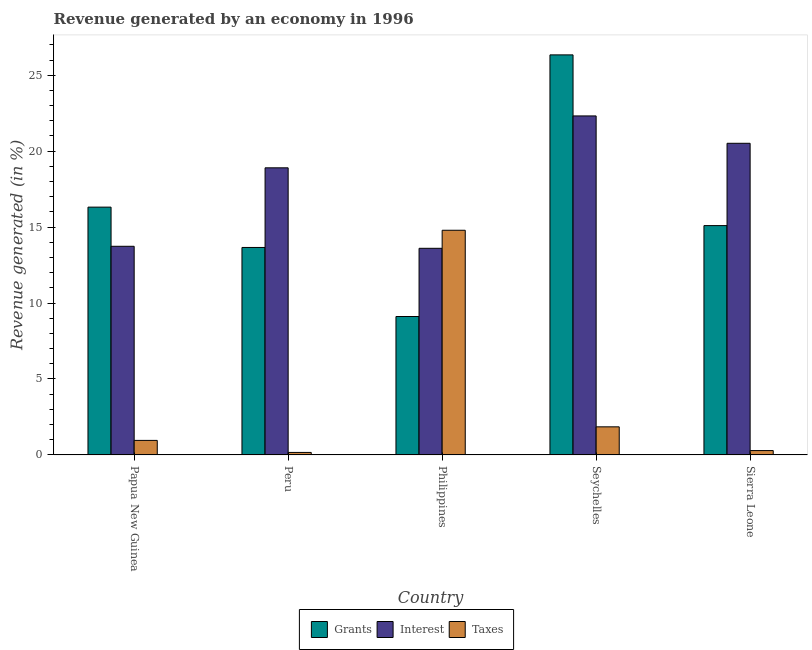How many different coloured bars are there?
Provide a short and direct response. 3. How many groups of bars are there?
Your answer should be very brief. 5. Are the number of bars per tick equal to the number of legend labels?
Your answer should be compact. Yes. How many bars are there on the 5th tick from the left?
Provide a succinct answer. 3. How many bars are there on the 2nd tick from the right?
Make the answer very short. 3. What is the label of the 1st group of bars from the left?
Keep it short and to the point. Papua New Guinea. In how many cases, is the number of bars for a given country not equal to the number of legend labels?
Give a very brief answer. 0. What is the percentage of revenue generated by interest in Philippines?
Your answer should be compact. 13.6. Across all countries, what is the maximum percentage of revenue generated by grants?
Provide a short and direct response. 26.34. Across all countries, what is the minimum percentage of revenue generated by taxes?
Keep it short and to the point. 0.16. In which country was the percentage of revenue generated by grants maximum?
Your response must be concise. Seychelles. In which country was the percentage of revenue generated by taxes minimum?
Your response must be concise. Peru. What is the total percentage of revenue generated by taxes in the graph?
Keep it short and to the point. 18.05. What is the difference between the percentage of revenue generated by taxes in Seychelles and that in Sierra Leone?
Make the answer very short. 1.56. What is the difference between the percentage of revenue generated by interest in Seychelles and the percentage of revenue generated by taxes in Peru?
Offer a very short reply. 22.16. What is the average percentage of revenue generated by interest per country?
Your answer should be compact. 17.82. What is the difference between the percentage of revenue generated by interest and percentage of revenue generated by grants in Philippines?
Give a very brief answer. 4.49. What is the ratio of the percentage of revenue generated by taxes in Peru to that in Sierra Leone?
Make the answer very short. 0.57. Is the difference between the percentage of revenue generated by taxes in Papua New Guinea and Peru greater than the difference between the percentage of revenue generated by interest in Papua New Guinea and Peru?
Your response must be concise. Yes. What is the difference between the highest and the second highest percentage of revenue generated by grants?
Offer a terse response. 10.03. What is the difference between the highest and the lowest percentage of revenue generated by interest?
Offer a terse response. 8.72. In how many countries, is the percentage of revenue generated by interest greater than the average percentage of revenue generated by interest taken over all countries?
Ensure brevity in your answer.  3. What does the 3rd bar from the left in Peru represents?
Ensure brevity in your answer.  Taxes. What does the 1st bar from the right in Papua New Guinea represents?
Your answer should be compact. Taxes. Are all the bars in the graph horizontal?
Keep it short and to the point. No. Does the graph contain any zero values?
Your answer should be compact. No. How are the legend labels stacked?
Make the answer very short. Horizontal. What is the title of the graph?
Offer a terse response. Revenue generated by an economy in 1996. Does "Spain" appear as one of the legend labels in the graph?
Keep it short and to the point. No. What is the label or title of the Y-axis?
Ensure brevity in your answer.  Revenue generated (in %). What is the Revenue generated (in %) in Grants in Papua New Guinea?
Provide a succinct answer. 16.32. What is the Revenue generated (in %) in Interest in Papua New Guinea?
Make the answer very short. 13.74. What is the Revenue generated (in %) of Taxes in Papua New Guinea?
Your answer should be compact. 0.96. What is the Revenue generated (in %) in Grants in Peru?
Keep it short and to the point. 13.66. What is the Revenue generated (in %) in Interest in Peru?
Make the answer very short. 18.9. What is the Revenue generated (in %) in Taxes in Peru?
Offer a very short reply. 0.16. What is the Revenue generated (in %) in Grants in Philippines?
Your answer should be very brief. 9.11. What is the Revenue generated (in %) in Interest in Philippines?
Provide a short and direct response. 13.6. What is the Revenue generated (in %) in Taxes in Philippines?
Make the answer very short. 14.79. What is the Revenue generated (in %) in Grants in Seychelles?
Make the answer very short. 26.34. What is the Revenue generated (in %) in Interest in Seychelles?
Your answer should be compact. 22.32. What is the Revenue generated (in %) in Taxes in Seychelles?
Provide a succinct answer. 1.85. What is the Revenue generated (in %) of Grants in Sierra Leone?
Offer a very short reply. 15.1. What is the Revenue generated (in %) in Interest in Sierra Leone?
Provide a succinct answer. 20.52. What is the Revenue generated (in %) of Taxes in Sierra Leone?
Your answer should be compact. 0.29. Across all countries, what is the maximum Revenue generated (in %) of Grants?
Keep it short and to the point. 26.34. Across all countries, what is the maximum Revenue generated (in %) of Interest?
Keep it short and to the point. 22.32. Across all countries, what is the maximum Revenue generated (in %) in Taxes?
Ensure brevity in your answer.  14.79. Across all countries, what is the minimum Revenue generated (in %) in Grants?
Ensure brevity in your answer.  9.11. Across all countries, what is the minimum Revenue generated (in %) in Interest?
Ensure brevity in your answer.  13.6. Across all countries, what is the minimum Revenue generated (in %) of Taxes?
Offer a very short reply. 0.16. What is the total Revenue generated (in %) of Grants in the graph?
Your response must be concise. 80.53. What is the total Revenue generated (in %) in Interest in the graph?
Ensure brevity in your answer.  89.09. What is the total Revenue generated (in %) of Taxes in the graph?
Keep it short and to the point. 18.05. What is the difference between the Revenue generated (in %) in Grants in Papua New Guinea and that in Peru?
Your answer should be very brief. 2.66. What is the difference between the Revenue generated (in %) of Interest in Papua New Guinea and that in Peru?
Give a very brief answer. -5.17. What is the difference between the Revenue generated (in %) of Taxes in Papua New Guinea and that in Peru?
Keep it short and to the point. 0.79. What is the difference between the Revenue generated (in %) of Grants in Papua New Guinea and that in Philippines?
Your answer should be compact. 7.2. What is the difference between the Revenue generated (in %) in Interest in Papua New Guinea and that in Philippines?
Make the answer very short. 0.13. What is the difference between the Revenue generated (in %) of Taxes in Papua New Guinea and that in Philippines?
Make the answer very short. -13.84. What is the difference between the Revenue generated (in %) of Grants in Papua New Guinea and that in Seychelles?
Your response must be concise. -10.03. What is the difference between the Revenue generated (in %) of Interest in Papua New Guinea and that in Seychelles?
Ensure brevity in your answer.  -8.58. What is the difference between the Revenue generated (in %) in Taxes in Papua New Guinea and that in Seychelles?
Keep it short and to the point. -0.89. What is the difference between the Revenue generated (in %) in Grants in Papua New Guinea and that in Sierra Leone?
Provide a short and direct response. 1.22. What is the difference between the Revenue generated (in %) of Interest in Papua New Guinea and that in Sierra Leone?
Offer a terse response. -6.78. What is the difference between the Revenue generated (in %) of Taxes in Papua New Guinea and that in Sierra Leone?
Your answer should be compact. 0.67. What is the difference between the Revenue generated (in %) of Grants in Peru and that in Philippines?
Your answer should be compact. 4.55. What is the difference between the Revenue generated (in %) of Interest in Peru and that in Philippines?
Your answer should be compact. 5.3. What is the difference between the Revenue generated (in %) of Taxes in Peru and that in Philippines?
Offer a very short reply. -14.63. What is the difference between the Revenue generated (in %) of Grants in Peru and that in Seychelles?
Your answer should be compact. -12.68. What is the difference between the Revenue generated (in %) in Interest in Peru and that in Seychelles?
Keep it short and to the point. -3.42. What is the difference between the Revenue generated (in %) of Taxes in Peru and that in Seychelles?
Provide a succinct answer. -1.68. What is the difference between the Revenue generated (in %) in Grants in Peru and that in Sierra Leone?
Give a very brief answer. -1.44. What is the difference between the Revenue generated (in %) of Interest in Peru and that in Sierra Leone?
Give a very brief answer. -1.62. What is the difference between the Revenue generated (in %) of Taxes in Peru and that in Sierra Leone?
Make the answer very short. -0.12. What is the difference between the Revenue generated (in %) of Grants in Philippines and that in Seychelles?
Provide a short and direct response. -17.23. What is the difference between the Revenue generated (in %) of Interest in Philippines and that in Seychelles?
Offer a very short reply. -8.72. What is the difference between the Revenue generated (in %) of Taxes in Philippines and that in Seychelles?
Ensure brevity in your answer.  12.94. What is the difference between the Revenue generated (in %) of Grants in Philippines and that in Sierra Leone?
Ensure brevity in your answer.  -5.98. What is the difference between the Revenue generated (in %) of Interest in Philippines and that in Sierra Leone?
Give a very brief answer. -6.92. What is the difference between the Revenue generated (in %) in Taxes in Philippines and that in Sierra Leone?
Keep it short and to the point. 14.51. What is the difference between the Revenue generated (in %) in Grants in Seychelles and that in Sierra Leone?
Ensure brevity in your answer.  11.24. What is the difference between the Revenue generated (in %) in Interest in Seychelles and that in Sierra Leone?
Keep it short and to the point. 1.8. What is the difference between the Revenue generated (in %) of Taxes in Seychelles and that in Sierra Leone?
Keep it short and to the point. 1.56. What is the difference between the Revenue generated (in %) of Grants in Papua New Guinea and the Revenue generated (in %) of Interest in Peru?
Your response must be concise. -2.59. What is the difference between the Revenue generated (in %) of Grants in Papua New Guinea and the Revenue generated (in %) of Taxes in Peru?
Offer a terse response. 16.15. What is the difference between the Revenue generated (in %) of Interest in Papua New Guinea and the Revenue generated (in %) of Taxes in Peru?
Provide a short and direct response. 13.57. What is the difference between the Revenue generated (in %) of Grants in Papua New Guinea and the Revenue generated (in %) of Interest in Philippines?
Your answer should be compact. 2.71. What is the difference between the Revenue generated (in %) in Grants in Papua New Guinea and the Revenue generated (in %) in Taxes in Philippines?
Offer a very short reply. 1.52. What is the difference between the Revenue generated (in %) of Interest in Papua New Guinea and the Revenue generated (in %) of Taxes in Philippines?
Give a very brief answer. -1.06. What is the difference between the Revenue generated (in %) in Grants in Papua New Guinea and the Revenue generated (in %) in Interest in Seychelles?
Offer a very short reply. -6.01. What is the difference between the Revenue generated (in %) in Grants in Papua New Guinea and the Revenue generated (in %) in Taxes in Seychelles?
Offer a very short reply. 14.47. What is the difference between the Revenue generated (in %) of Interest in Papua New Guinea and the Revenue generated (in %) of Taxes in Seychelles?
Offer a very short reply. 11.89. What is the difference between the Revenue generated (in %) of Grants in Papua New Guinea and the Revenue generated (in %) of Interest in Sierra Leone?
Your response must be concise. -4.2. What is the difference between the Revenue generated (in %) in Grants in Papua New Guinea and the Revenue generated (in %) in Taxes in Sierra Leone?
Give a very brief answer. 16.03. What is the difference between the Revenue generated (in %) of Interest in Papua New Guinea and the Revenue generated (in %) of Taxes in Sierra Leone?
Keep it short and to the point. 13.45. What is the difference between the Revenue generated (in %) in Grants in Peru and the Revenue generated (in %) in Interest in Philippines?
Make the answer very short. 0.06. What is the difference between the Revenue generated (in %) of Grants in Peru and the Revenue generated (in %) of Taxes in Philippines?
Provide a short and direct response. -1.13. What is the difference between the Revenue generated (in %) in Interest in Peru and the Revenue generated (in %) in Taxes in Philippines?
Keep it short and to the point. 4.11. What is the difference between the Revenue generated (in %) in Grants in Peru and the Revenue generated (in %) in Interest in Seychelles?
Your answer should be very brief. -8.66. What is the difference between the Revenue generated (in %) in Grants in Peru and the Revenue generated (in %) in Taxes in Seychelles?
Your response must be concise. 11.81. What is the difference between the Revenue generated (in %) in Interest in Peru and the Revenue generated (in %) in Taxes in Seychelles?
Offer a very short reply. 17.05. What is the difference between the Revenue generated (in %) of Grants in Peru and the Revenue generated (in %) of Interest in Sierra Leone?
Give a very brief answer. -6.86. What is the difference between the Revenue generated (in %) of Grants in Peru and the Revenue generated (in %) of Taxes in Sierra Leone?
Provide a succinct answer. 13.37. What is the difference between the Revenue generated (in %) in Interest in Peru and the Revenue generated (in %) in Taxes in Sierra Leone?
Your answer should be compact. 18.62. What is the difference between the Revenue generated (in %) of Grants in Philippines and the Revenue generated (in %) of Interest in Seychelles?
Ensure brevity in your answer.  -13.21. What is the difference between the Revenue generated (in %) in Grants in Philippines and the Revenue generated (in %) in Taxes in Seychelles?
Provide a succinct answer. 7.26. What is the difference between the Revenue generated (in %) of Interest in Philippines and the Revenue generated (in %) of Taxes in Seychelles?
Your answer should be compact. 11.76. What is the difference between the Revenue generated (in %) in Grants in Philippines and the Revenue generated (in %) in Interest in Sierra Leone?
Your answer should be compact. -11.4. What is the difference between the Revenue generated (in %) of Grants in Philippines and the Revenue generated (in %) of Taxes in Sierra Leone?
Offer a very short reply. 8.83. What is the difference between the Revenue generated (in %) in Interest in Philippines and the Revenue generated (in %) in Taxes in Sierra Leone?
Offer a very short reply. 13.32. What is the difference between the Revenue generated (in %) in Grants in Seychelles and the Revenue generated (in %) in Interest in Sierra Leone?
Your answer should be compact. 5.82. What is the difference between the Revenue generated (in %) in Grants in Seychelles and the Revenue generated (in %) in Taxes in Sierra Leone?
Offer a terse response. 26.05. What is the difference between the Revenue generated (in %) of Interest in Seychelles and the Revenue generated (in %) of Taxes in Sierra Leone?
Make the answer very short. 22.03. What is the average Revenue generated (in %) of Grants per country?
Your response must be concise. 16.11. What is the average Revenue generated (in %) in Interest per country?
Your answer should be very brief. 17.82. What is the average Revenue generated (in %) in Taxes per country?
Keep it short and to the point. 3.61. What is the difference between the Revenue generated (in %) in Grants and Revenue generated (in %) in Interest in Papua New Guinea?
Offer a very short reply. 2.58. What is the difference between the Revenue generated (in %) of Grants and Revenue generated (in %) of Taxes in Papua New Guinea?
Offer a very short reply. 15.36. What is the difference between the Revenue generated (in %) in Interest and Revenue generated (in %) in Taxes in Papua New Guinea?
Keep it short and to the point. 12.78. What is the difference between the Revenue generated (in %) in Grants and Revenue generated (in %) in Interest in Peru?
Your answer should be very brief. -5.24. What is the difference between the Revenue generated (in %) of Grants and Revenue generated (in %) of Taxes in Peru?
Make the answer very short. 13.5. What is the difference between the Revenue generated (in %) of Interest and Revenue generated (in %) of Taxes in Peru?
Make the answer very short. 18.74. What is the difference between the Revenue generated (in %) in Grants and Revenue generated (in %) in Interest in Philippines?
Offer a terse response. -4.49. What is the difference between the Revenue generated (in %) of Grants and Revenue generated (in %) of Taxes in Philippines?
Provide a short and direct response. -5.68. What is the difference between the Revenue generated (in %) of Interest and Revenue generated (in %) of Taxes in Philippines?
Your answer should be compact. -1.19. What is the difference between the Revenue generated (in %) in Grants and Revenue generated (in %) in Interest in Seychelles?
Keep it short and to the point. 4.02. What is the difference between the Revenue generated (in %) in Grants and Revenue generated (in %) in Taxes in Seychelles?
Give a very brief answer. 24.49. What is the difference between the Revenue generated (in %) in Interest and Revenue generated (in %) in Taxes in Seychelles?
Provide a succinct answer. 20.47. What is the difference between the Revenue generated (in %) of Grants and Revenue generated (in %) of Interest in Sierra Leone?
Offer a very short reply. -5.42. What is the difference between the Revenue generated (in %) of Grants and Revenue generated (in %) of Taxes in Sierra Leone?
Offer a terse response. 14.81. What is the difference between the Revenue generated (in %) in Interest and Revenue generated (in %) in Taxes in Sierra Leone?
Your answer should be very brief. 20.23. What is the ratio of the Revenue generated (in %) of Grants in Papua New Guinea to that in Peru?
Offer a terse response. 1.19. What is the ratio of the Revenue generated (in %) of Interest in Papua New Guinea to that in Peru?
Offer a very short reply. 0.73. What is the ratio of the Revenue generated (in %) of Taxes in Papua New Guinea to that in Peru?
Your answer should be compact. 5.8. What is the ratio of the Revenue generated (in %) in Grants in Papua New Guinea to that in Philippines?
Keep it short and to the point. 1.79. What is the ratio of the Revenue generated (in %) of Interest in Papua New Guinea to that in Philippines?
Your answer should be very brief. 1.01. What is the ratio of the Revenue generated (in %) in Taxes in Papua New Guinea to that in Philippines?
Your answer should be very brief. 0.06. What is the ratio of the Revenue generated (in %) of Grants in Papua New Guinea to that in Seychelles?
Offer a very short reply. 0.62. What is the ratio of the Revenue generated (in %) in Interest in Papua New Guinea to that in Seychelles?
Provide a short and direct response. 0.62. What is the ratio of the Revenue generated (in %) of Taxes in Papua New Guinea to that in Seychelles?
Make the answer very short. 0.52. What is the ratio of the Revenue generated (in %) in Grants in Papua New Guinea to that in Sierra Leone?
Provide a short and direct response. 1.08. What is the ratio of the Revenue generated (in %) in Interest in Papua New Guinea to that in Sierra Leone?
Provide a succinct answer. 0.67. What is the ratio of the Revenue generated (in %) of Taxes in Papua New Guinea to that in Sierra Leone?
Ensure brevity in your answer.  3.34. What is the ratio of the Revenue generated (in %) of Grants in Peru to that in Philippines?
Keep it short and to the point. 1.5. What is the ratio of the Revenue generated (in %) of Interest in Peru to that in Philippines?
Your answer should be compact. 1.39. What is the ratio of the Revenue generated (in %) of Taxes in Peru to that in Philippines?
Keep it short and to the point. 0.01. What is the ratio of the Revenue generated (in %) in Grants in Peru to that in Seychelles?
Your response must be concise. 0.52. What is the ratio of the Revenue generated (in %) in Interest in Peru to that in Seychelles?
Keep it short and to the point. 0.85. What is the ratio of the Revenue generated (in %) in Taxes in Peru to that in Seychelles?
Your answer should be very brief. 0.09. What is the ratio of the Revenue generated (in %) of Grants in Peru to that in Sierra Leone?
Make the answer very short. 0.9. What is the ratio of the Revenue generated (in %) in Interest in Peru to that in Sierra Leone?
Keep it short and to the point. 0.92. What is the ratio of the Revenue generated (in %) of Taxes in Peru to that in Sierra Leone?
Your answer should be compact. 0.57. What is the ratio of the Revenue generated (in %) of Grants in Philippines to that in Seychelles?
Give a very brief answer. 0.35. What is the ratio of the Revenue generated (in %) in Interest in Philippines to that in Seychelles?
Your response must be concise. 0.61. What is the ratio of the Revenue generated (in %) in Taxes in Philippines to that in Seychelles?
Offer a terse response. 8. What is the ratio of the Revenue generated (in %) in Grants in Philippines to that in Sierra Leone?
Provide a short and direct response. 0.6. What is the ratio of the Revenue generated (in %) in Interest in Philippines to that in Sierra Leone?
Provide a short and direct response. 0.66. What is the ratio of the Revenue generated (in %) of Taxes in Philippines to that in Sierra Leone?
Your response must be concise. 51.58. What is the ratio of the Revenue generated (in %) of Grants in Seychelles to that in Sierra Leone?
Keep it short and to the point. 1.74. What is the ratio of the Revenue generated (in %) of Interest in Seychelles to that in Sierra Leone?
Offer a terse response. 1.09. What is the ratio of the Revenue generated (in %) in Taxes in Seychelles to that in Sierra Leone?
Your answer should be compact. 6.45. What is the difference between the highest and the second highest Revenue generated (in %) in Grants?
Your answer should be very brief. 10.03. What is the difference between the highest and the second highest Revenue generated (in %) in Interest?
Make the answer very short. 1.8. What is the difference between the highest and the second highest Revenue generated (in %) in Taxes?
Give a very brief answer. 12.94. What is the difference between the highest and the lowest Revenue generated (in %) in Grants?
Provide a succinct answer. 17.23. What is the difference between the highest and the lowest Revenue generated (in %) in Interest?
Your response must be concise. 8.72. What is the difference between the highest and the lowest Revenue generated (in %) in Taxes?
Your response must be concise. 14.63. 